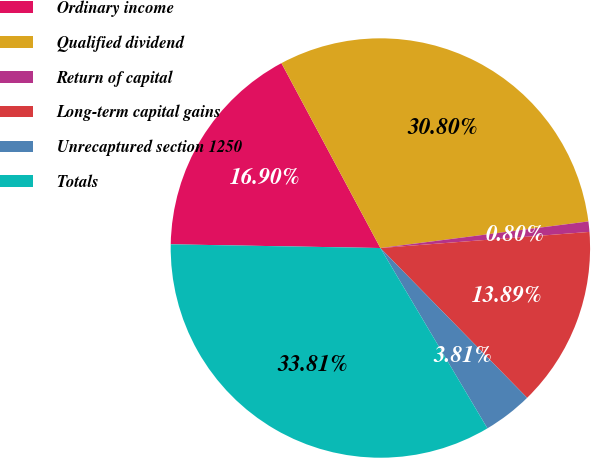Convert chart. <chart><loc_0><loc_0><loc_500><loc_500><pie_chart><fcel>Ordinary income<fcel>Qualified dividend<fcel>Return of capital<fcel>Long-term capital gains<fcel>Unrecaptured section 1250<fcel>Totals<nl><fcel>16.9%<fcel>30.8%<fcel>0.8%<fcel>13.89%<fcel>3.81%<fcel>33.81%<nl></chart> 